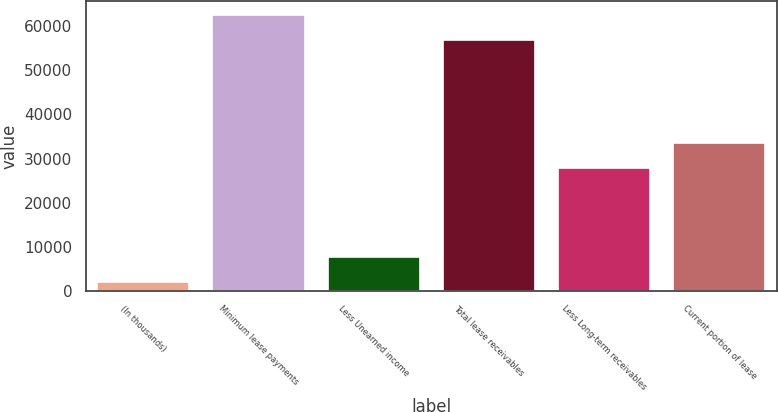<chart> <loc_0><loc_0><loc_500><loc_500><bar_chart><fcel>(In thousands)<fcel>Minimum lease payments<fcel>Less Unearned income<fcel>Total lease receivables<fcel>Less Long-term receivables<fcel>Current portion of lease<nl><fcel>2016<fcel>62633.5<fcel>7731.5<fcel>56918<fcel>27790<fcel>33505.5<nl></chart> 